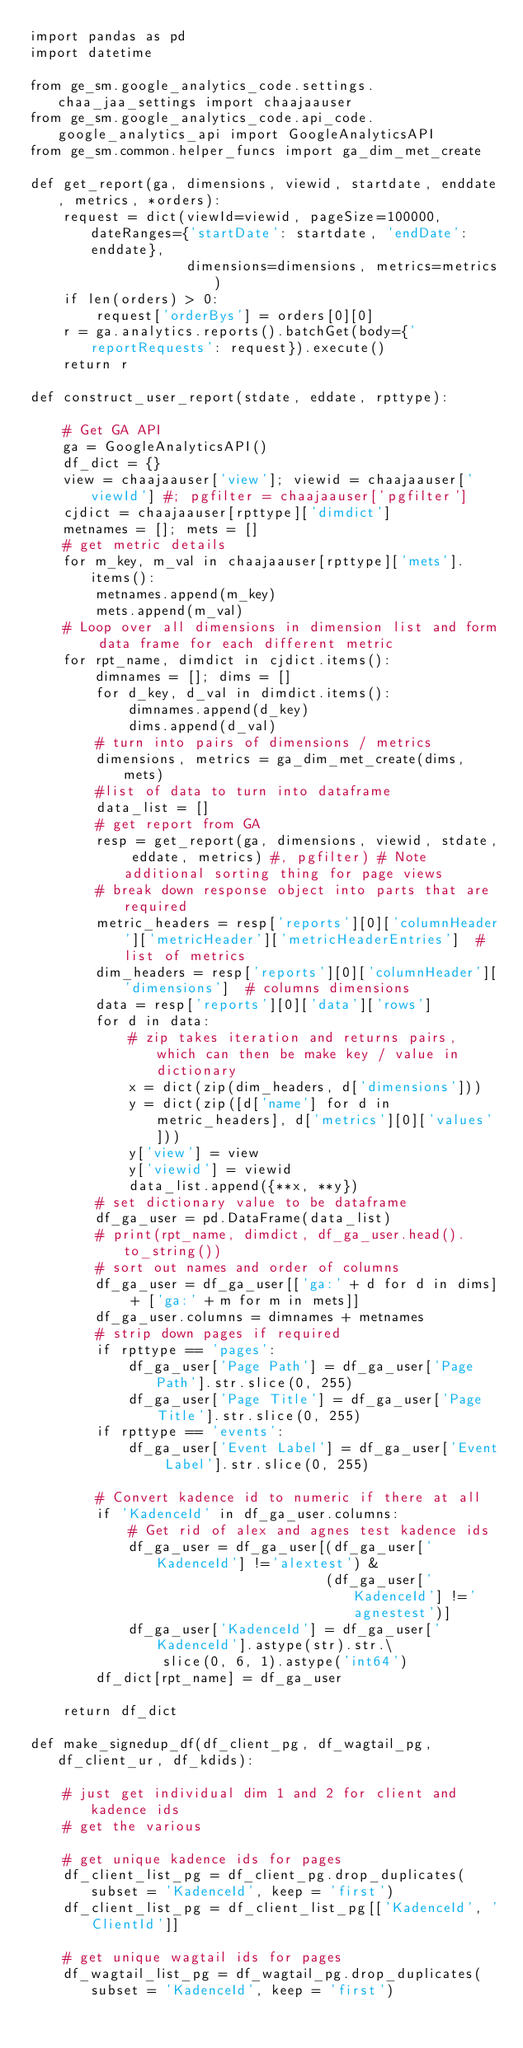Convert code to text. <code><loc_0><loc_0><loc_500><loc_500><_Python_>import pandas as pd
import datetime

from ge_sm.google_analytics_code.settings.chaa_jaa_settings import chaajaauser
from ge_sm.google_analytics_code.api_code.google_analytics_api import GoogleAnalyticsAPI
from ge_sm.common.helper_funcs import ga_dim_met_create

def get_report(ga, dimensions, viewid, startdate, enddate, metrics, *orders):
    request = dict(viewId=viewid, pageSize=100000, dateRanges={'startDate': startdate, 'endDate': enddate},
                   dimensions=dimensions, metrics=metrics)
    if len(orders) > 0:
        request['orderBys'] = orders[0][0]
    r = ga.analytics.reports().batchGet(body={'reportRequests': request}).execute()
    return r

def construct_user_report(stdate, eddate, rpttype):

    # Get GA API
    ga = GoogleAnalyticsAPI()
    df_dict = {}
    view = chaajaauser['view']; viewid = chaajaauser['viewId'] #; pgfilter = chaajaauser['pgfilter']
    cjdict = chaajaauser[rpttype]['dimdict']
    metnames = []; mets = []
    # get metric details
    for m_key, m_val in chaajaauser[rpttype]['mets'].items():
        metnames.append(m_key)
        mets.append(m_val)
    # Loop over all dimensions in dimension list and form data frame for each different metric
    for rpt_name, dimdict in cjdict.items():
        dimnames = []; dims = []
        for d_key, d_val in dimdict.items():
            dimnames.append(d_key)
            dims.append(d_val)
        # turn into pairs of dimensions / metrics
        dimensions, metrics = ga_dim_met_create(dims, mets)
        #list of data to turn into dataframe
        data_list = []
        # get report from GA
        resp = get_report(ga, dimensions, viewid, stdate, eddate, metrics) #, pgfilter) # Note additional sorting thing for page views
        # break down response object into parts that are required
        metric_headers = resp['reports'][0]['columnHeader']['metricHeader']['metricHeaderEntries']  # list of metrics
        dim_headers = resp['reports'][0]['columnHeader']['dimensions']  # columns dimensions
        data = resp['reports'][0]['data']['rows']
        for d in data:
            # zip takes iteration and returns pairs, which can then be make key / value in dictionary
            x = dict(zip(dim_headers, d['dimensions']))
            y = dict(zip([d['name'] for d in metric_headers], d['metrics'][0]['values']))
            y['view'] = view
            y['viewid'] = viewid
            data_list.append({**x, **y})
        # set dictionary value to be dataframe
        df_ga_user = pd.DataFrame(data_list)
        # print(rpt_name, dimdict, df_ga_user.head().to_string())
        # sort out names and order of columns
        df_ga_user = df_ga_user[['ga:' + d for d in dims] + ['ga:' + m for m in mets]]
        df_ga_user.columns = dimnames + metnames
        # strip down pages if required
        if rpttype == 'pages':
            df_ga_user['Page Path'] = df_ga_user['Page Path'].str.slice(0, 255)
            df_ga_user['Page Title'] = df_ga_user['Page Title'].str.slice(0, 255)
        if rpttype == 'events':
            df_ga_user['Event Label'] = df_ga_user['Event Label'].str.slice(0, 255)

        # Convert kadence id to numeric if there at all
        if 'KadenceId' in df_ga_user.columns:
            # Get rid of alex and agnes test kadence ids
            df_ga_user = df_ga_user[(df_ga_user['KadenceId'] !='alextest') &
                                    (df_ga_user['KadenceId'] !='agnestest')]
            df_ga_user['KadenceId'] = df_ga_user['KadenceId'].astype(str).str.\
                slice(0, 6, 1).astype('int64')
        df_dict[rpt_name] = df_ga_user

    return df_dict

def make_signedup_df(df_client_pg, df_wagtail_pg, df_client_ur, df_kdids):

    # just get individual dim 1 and 2 for client and kadence ids
    # get the various

    # get unique kadence ids for pages
    df_client_list_pg = df_client_pg.drop_duplicates(subset = 'KadenceId', keep = 'first')
    df_client_list_pg = df_client_list_pg[['KadenceId', 'ClientId']]

    # get unique wagtail ids for pages
    df_wagtail_list_pg = df_wagtail_pg.drop_duplicates(subset = 'KadenceId', keep = 'first')</code> 